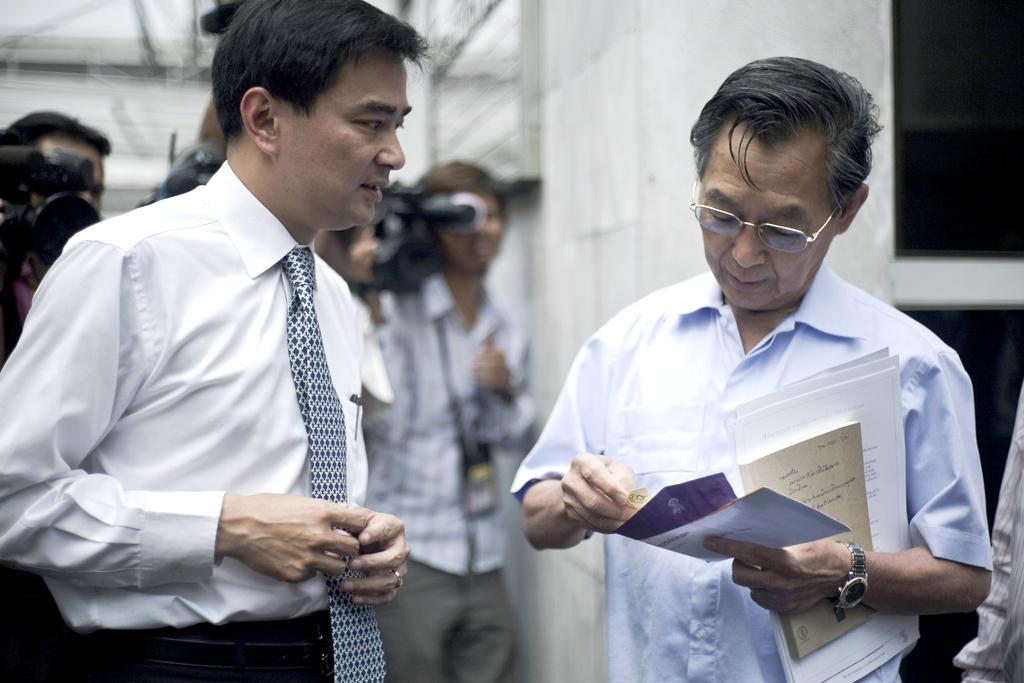In one or two sentences, can you explain what this image depicts? In this picture we can see some people are standing, a man on the right side is holding some papers, in the background we can see camera, we can also see a wall in the background. 